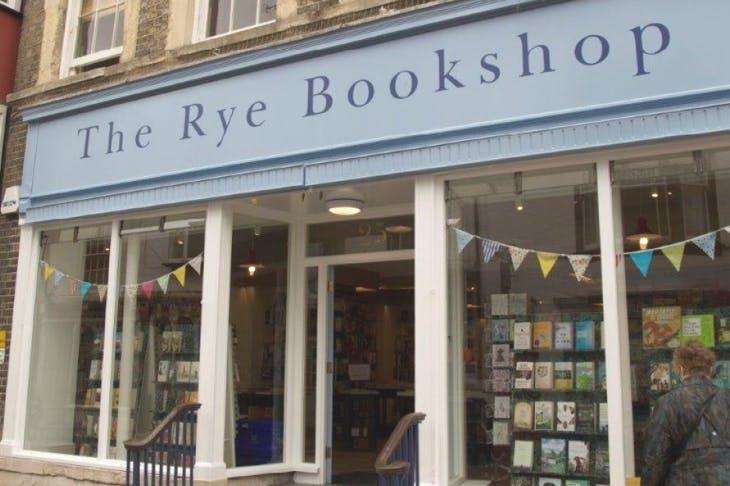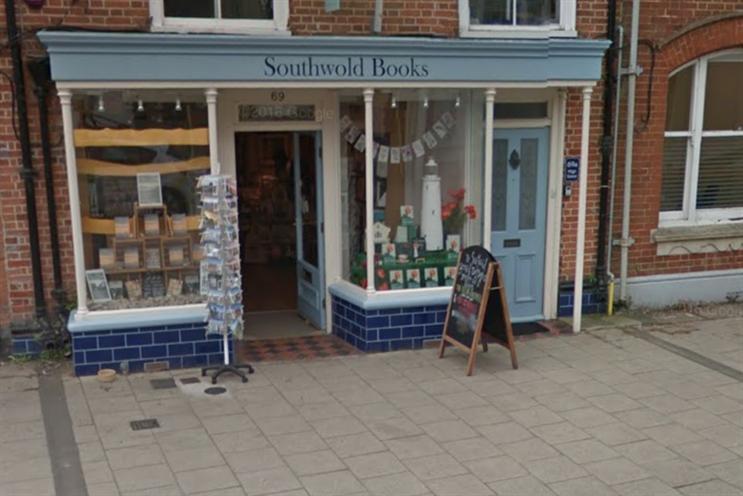The first image is the image on the left, the second image is the image on the right. Examine the images to the left and right. Is the description "The bookstore on the right has a banner of pennants in different shades of blue." accurate? Answer yes or no. No. The first image is the image on the left, the second image is the image on the right. For the images displayed, is the sentence "There is an open door between two display windows of a shelf of books and at the bottom there a blue bricks." factually correct? Answer yes or no. Yes. 